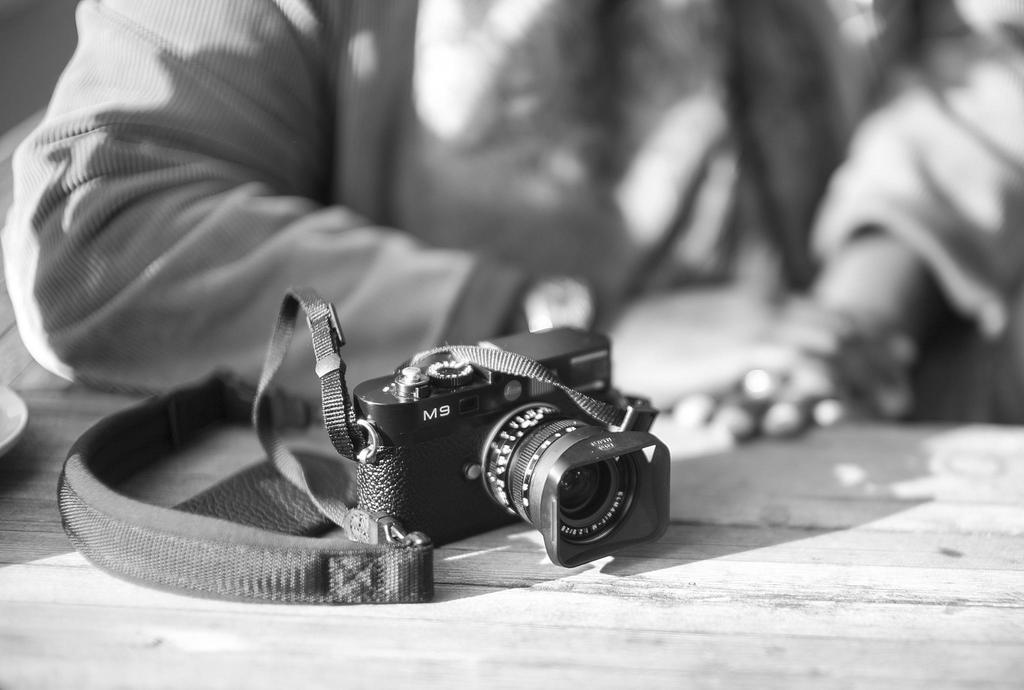<image>
Relay a brief, clear account of the picture shown. A black and white photo of a camera labeled M9 in front of a person. 